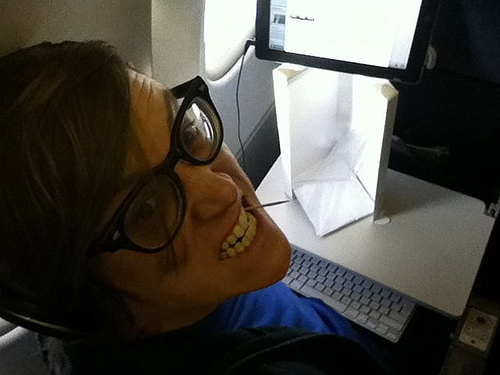What color does the keyboard have? The keyboard is gray. 